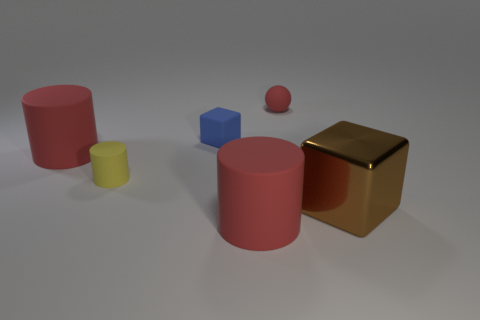What is the material of the blue thing that is the same size as the yellow matte object?
Give a very brief answer. Rubber. Is there a red rubber object that has the same size as the blue thing?
Keep it short and to the point. Yes. There is a red matte cylinder behind the large cube; what is its size?
Your response must be concise. Large. The shiny block has what size?
Your answer should be very brief. Large. What number of spheres are red matte objects or small green metal objects?
Give a very brief answer. 1. There is a sphere that is made of the same material as the yellow cylinder; what size is it?
Your answer should be compact. Small. How many matte things are the same color as the big block?
Provide a succinct answer. 0. Are there any small red rubber things left of the rubber cube?
Your answer should be very brief. No. Do the tiny yellow matte thing and the thing that is right of the red ball have the same shape?
Make the answer very short. No. What number of things are big cylinders in front of the metal object or big red metal things?
Make the answer very short. 1. 